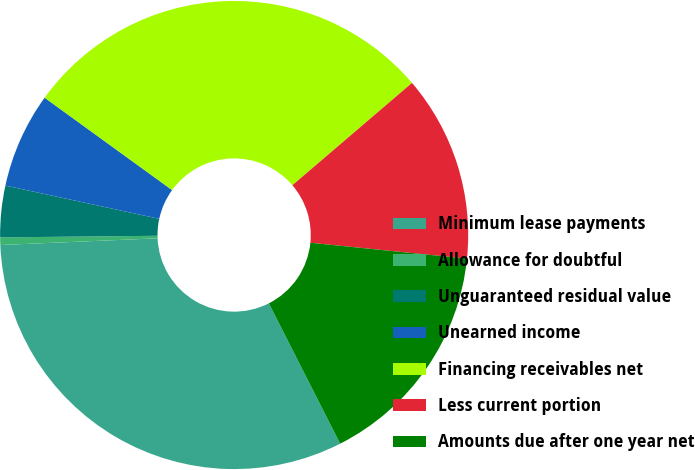Convert chart. <chart><loc_0><loc_0><loc_500><loc_500><pie_chart><fcel>Minimum lease payments<fcel>Allowance for doubtful<fcel>Unguaranteed residual value<fcel>Unearned income<fcel>Financing receivables net<fcel>Less current portion<fcel>Amounts due after one year net<nl><fcel>31.8%<fcel>0.52%<fcel>3.55%<fcel>6.59%<fcel>28.76%<fcel>12.87%<fcel>15.91%<nl></chart> 